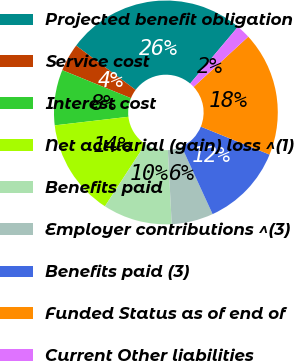Convert chart to OTSL. <chart><loc_0><loc_0><loc_500><loc_500><pie_chart><fcel>Projected benefit obligation<fcel>Service cost<fcel>Interest cost<fcel>Net actuarial (gain) loss ^(1)<fcel>Benefits paid<fcel>Employer contributions ^(3)<fcel>Benefits paid (3)<fcel>Funded Status as of end of<fcel>Current Other liabilities<nl><fcel>25.95%<fcel>4.02%<fcel>8.01%<fcel>13.99%<fcel>10.0%<fcel>6.02%<fcel>12.0%<fcel>17.98%<fcel>2.03%<nl></chart> 